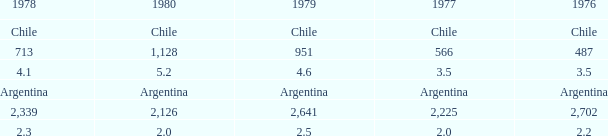What is 1976 when 1977 is 3.5? 3.5. 